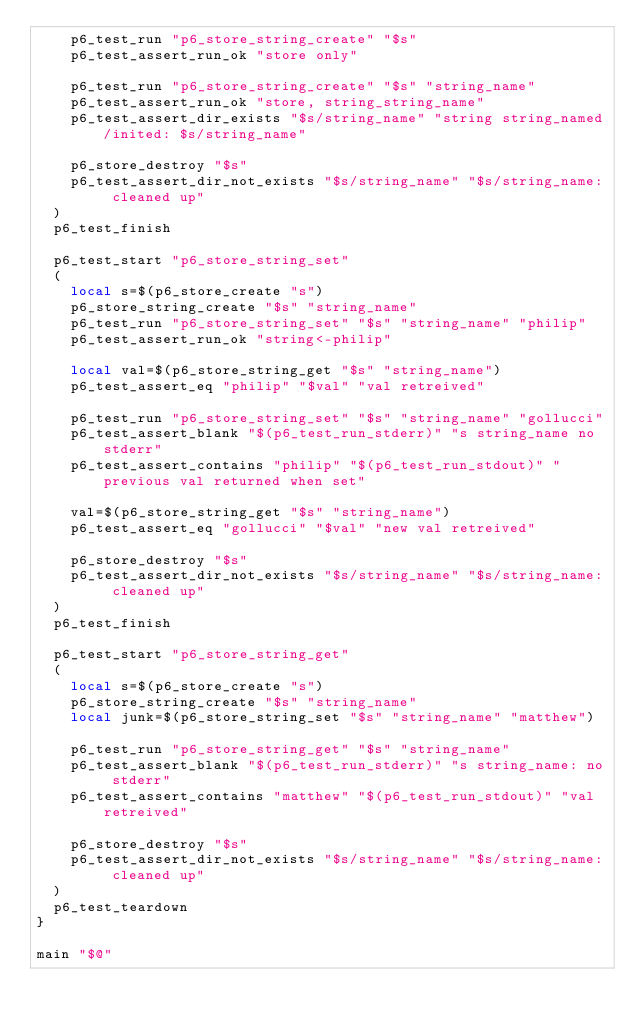Convert code to text. <code><loc_0><loc_0><loc_500><loc_500><_Bash_>		p6_test_run "p6_store_string_create" "$s"
		p6_test_assert_run_ok "store only"

		p6_test_run "p6_store_string_create" "$s" "string_name"
		p6_test_assert_run_ok "store, string_string_name"
		p6_test_assert_dir_exists "$s/string_name" "string string_named/inited: $s/string_name"

		p6_store_destroy "$s"
		p6_test_assert_dir_not_exists "$s/string_name" "$s/string_name: cleaned up"
	)
	p6_test_finish

	p6_test_start "p6_store_string_set"
	(
		local s=$(p6_store_create "s")
		p6_store_string_create "$s" "string_name"
		p6_test_run "p6_store_string_set" "$s" "string_name" "philip"
		p6_test_assert_run_ok "string<-philip"

		local val=$(p6_store_string_get "$s" "string_name")
		p6_test_assert_eq "philip" "$val" "val retreived"

		p6_test_run "p6_store_string_set" "$s" "string_name" "gollucci"
		p6_test_assert_blank "$(p6_test_run_stderr)" "s string_name no stderr"
		p6_test_assert_contains "philip" "$(p6_test_run_stdout)" "previous val returned when set"

		val=$(p6_store_string_get "$s" "string_name")
		p6_test_assert_eq "gollucci" "$val" "new val retreived"

		p6_store_destroy "$s"
		p6_test_assert_dir_not_exists "$s/string_name" "$s/string_name: cleaned up"
	)
	p6_test_finish

	p6_test_start "p6_store_string_get"
	(
		local s=$(p6_store_create "s")
		p6_store_string_create "$s" "string_name"
		local junk=$(p6_store_string_set "$s" "string_name" "matthew")

		p6_test_run "p6_store_string_get" "$s" "string_name"
		p6_test_assert_blank "$(p6_test_run_stderr)" "s string_name: no stderr"
		p6_test_assert_contains "matthew" "$(p6_test_run_stdout)" "val retreived"

		p6_store_destroy "$s"
		p6_test_assert_dir_not_exists "$s/string_name" "$s/string_name: cleaned up"
	)
	p6_test_teardown
}

main "$@"
</code> 